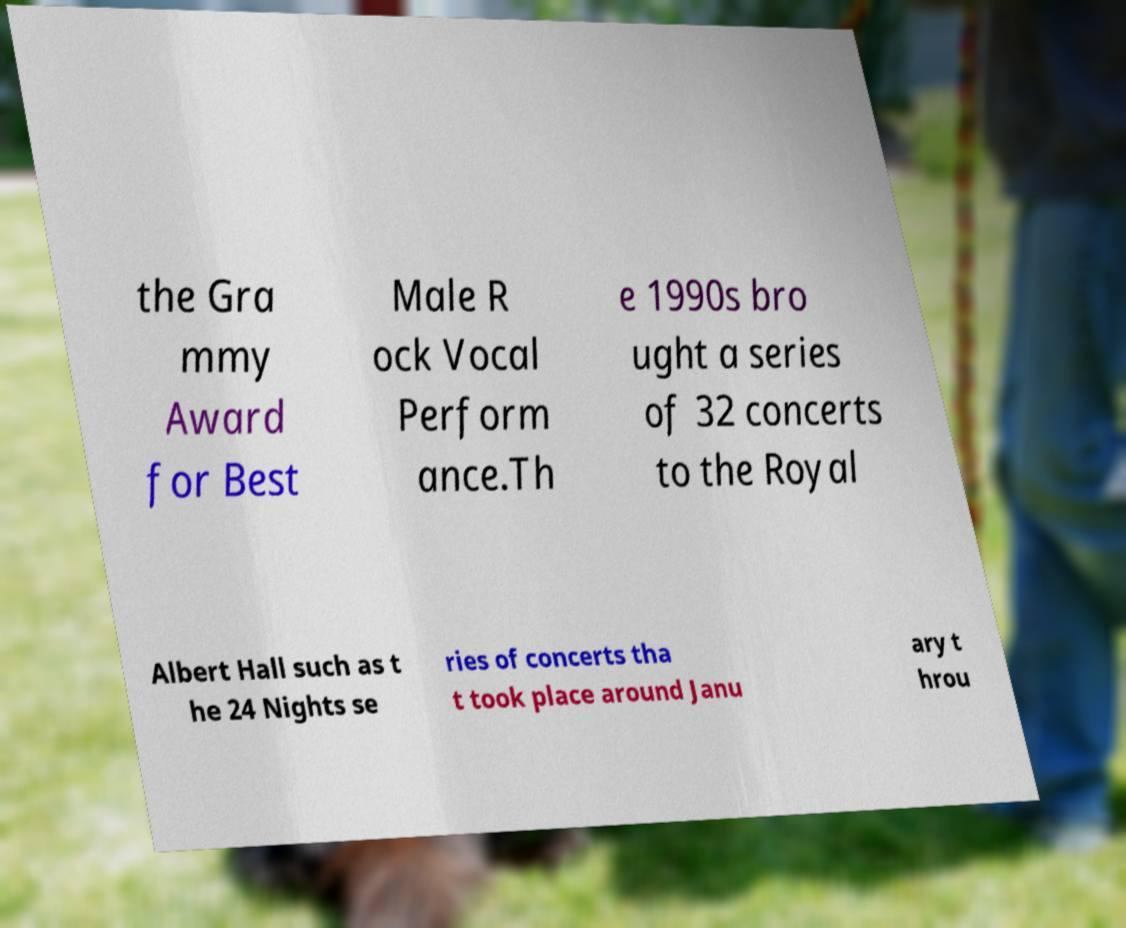There's text embedded in this image that I need extracted. Can you transcribe it verbatim? the Gra mmy Award for Best Male R ock Vocal Perform ance.Th e 1990s bro ught a series of 32 concerts to the Royal Albert Hall such as t he 24 Nights se ries of concerts tha t took place around Janu ary t hrou 